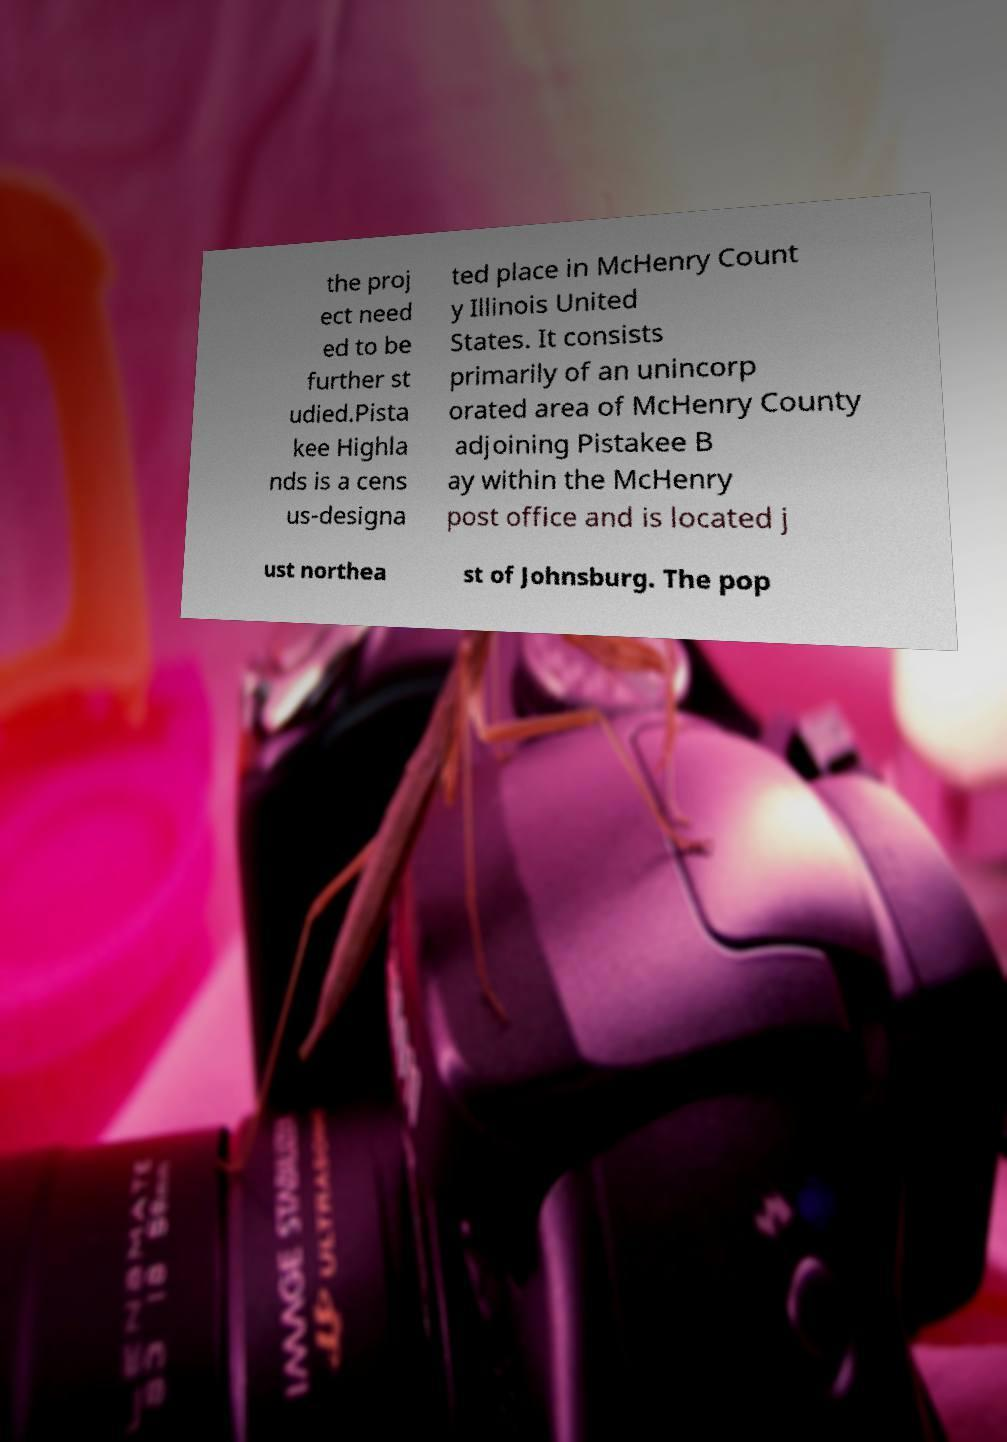Can you read and provide the text displayed in the image?This photo seems to have some interesting text. Can you extract and type it out for me? the proj ect need ed to be further st udied.Pista kee Highla nds is a cens us-designa ted place in McHenry Count y Illinois United States. It consists primarily of an unincorp orated area of McHenry County adjoining Pistakee B ay within the McHenry post office and is located j ust northea st of Johnsburg. The pop 